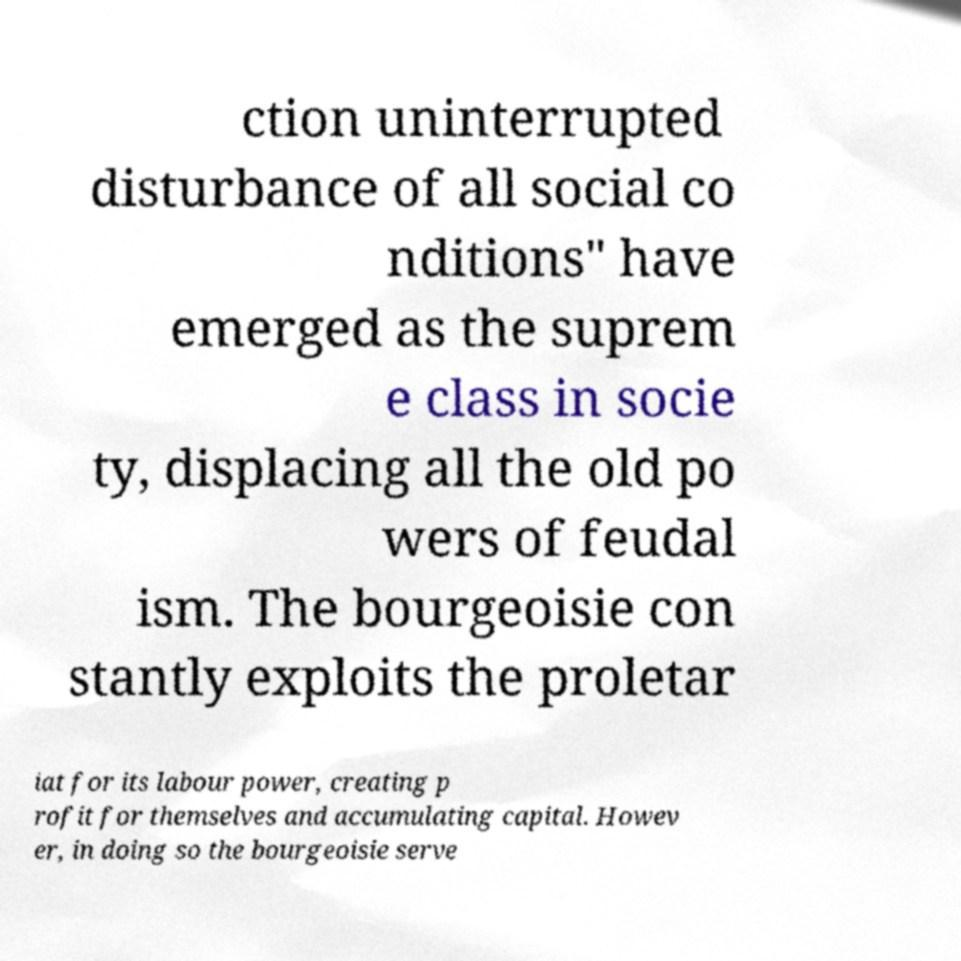Can you read and provide the text displayed in the image?This photo seems to have some interesting text. Can you extract and type it out for me? ction uninterrupted disturbance of all social co nditions" have emerged as the suprem e class in socie ty, displacing all the old po wers of feudal ism. The bourgeoisie con stantly exploits the proletar iat for its labour power, creating p rofit for themselves and accumulating capital. Howev er, in doing so the bourgeoisie serve 